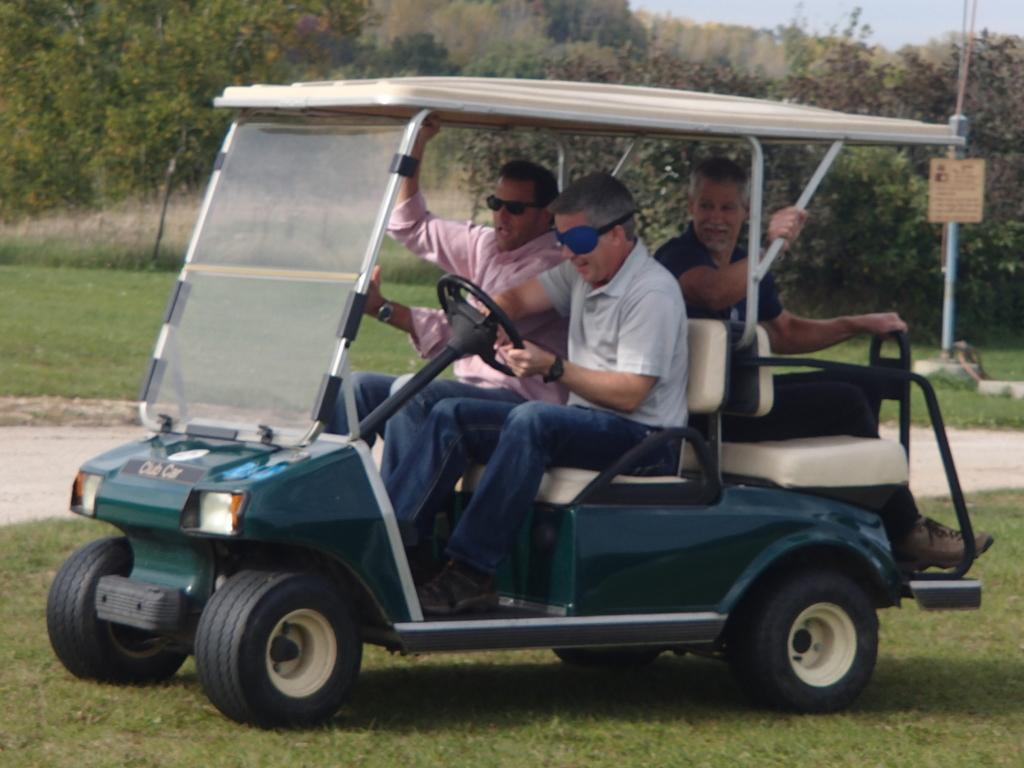How many people are in the image? There are three men in the image. What are the men doing in the image? The men are traveling in a car. What can be seen in the background of the image? There are trees visible in the background of the image. What type of vegetation covers the ground in the image? The ground is covered with grass. What hobbies do the ants have in the image? There are no ants present in the image, so their hobbies cannot be determined. 